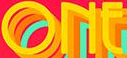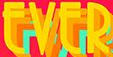What words are shown in these images in order, separated by a semicolon? ONE; EVER 